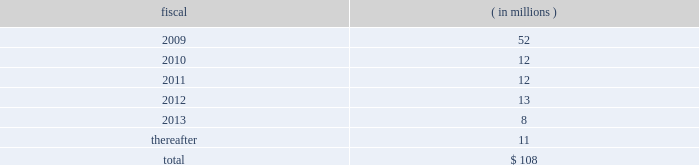Visa inc .
Notes to consolidated financial statements 2014 ( continued ) september 30 , 2008 ( in millions , except as noted ) secured notes series b-1995 lease agreement in september 1995 , a real estate partnership owned jointly by visa u.s.a .
And visa international issued notes that are secured by certain office properties and facilities in california which are used by the company through a lease financing of net-leased office space ( 201c1995 lease agreement 201d ) .
Series b of these notes , totaling $ 27 million , were issued with an interest rate of 7.83% ( 7.83 % ) and a stated maturity of september 15 , 2015 , and are payable monthly with interest-only payments for the first ten years and payments of interest and principal for the remainder of the term .
Series b debt issuance costs of $ 0.3 million and a $ 0.8 million loss on termination of a forward contract are being amortized on a straight- line basis over the life of the notes .
The settlement entered into in connection with visa check/ master money antitrust litigation had triggered an event of default under the 1995 lease agreement .
Accordingly , the related debt was classified as a current liability at september 30 , 2007 .
In may 2008 , visa inc. , visa u.s.a .
And visa international executed an amendment and waiver to the 1995 lease agreement ( 201camended 1995 lease agreement 201d ) , curing the default and including a guarantee of remaining obligations under the agreement by visa inc .
The interest terms remained unchanged .
Future principal payments future principal payments on the company 2019s outstanding debt are as follows: .
U.s .
Commercial paper program visa international maintains a u.s .
Commercial paper program to support its working capital requirements and for general corporate purposes .
This program allows the company to issue up to $ 500 million of unsecured debt securities , with maturities up to 270 days from the date of issuance and at interest rates generally extended to companies with comparable credit ratings .
At september 30 , 2008 , the company had no outstanding obligations under this program .
Revolving credit facilities on february 15 , 2008 , visa inc .
Entered into a $ 3.0 billion five-year revolving credit facility ( the 201cfebruary 2008 agreement 201d ) which replaced visa international 2019s $ 2.25 billion credit facility .
The february 2008 agreement matures on february 15 , 2013 and contains covenants and events of defaults customary for facilities of this type .
At september 30 , 2008 , the company is in compliance with all covenants with respect to the revolving credit facility. .
In 2008 what was the percent of the total future principal payments on the company 2019s outstanding debt that was due in 2009? 
Computations: (52 / 108)
Answer: 0.48148. 